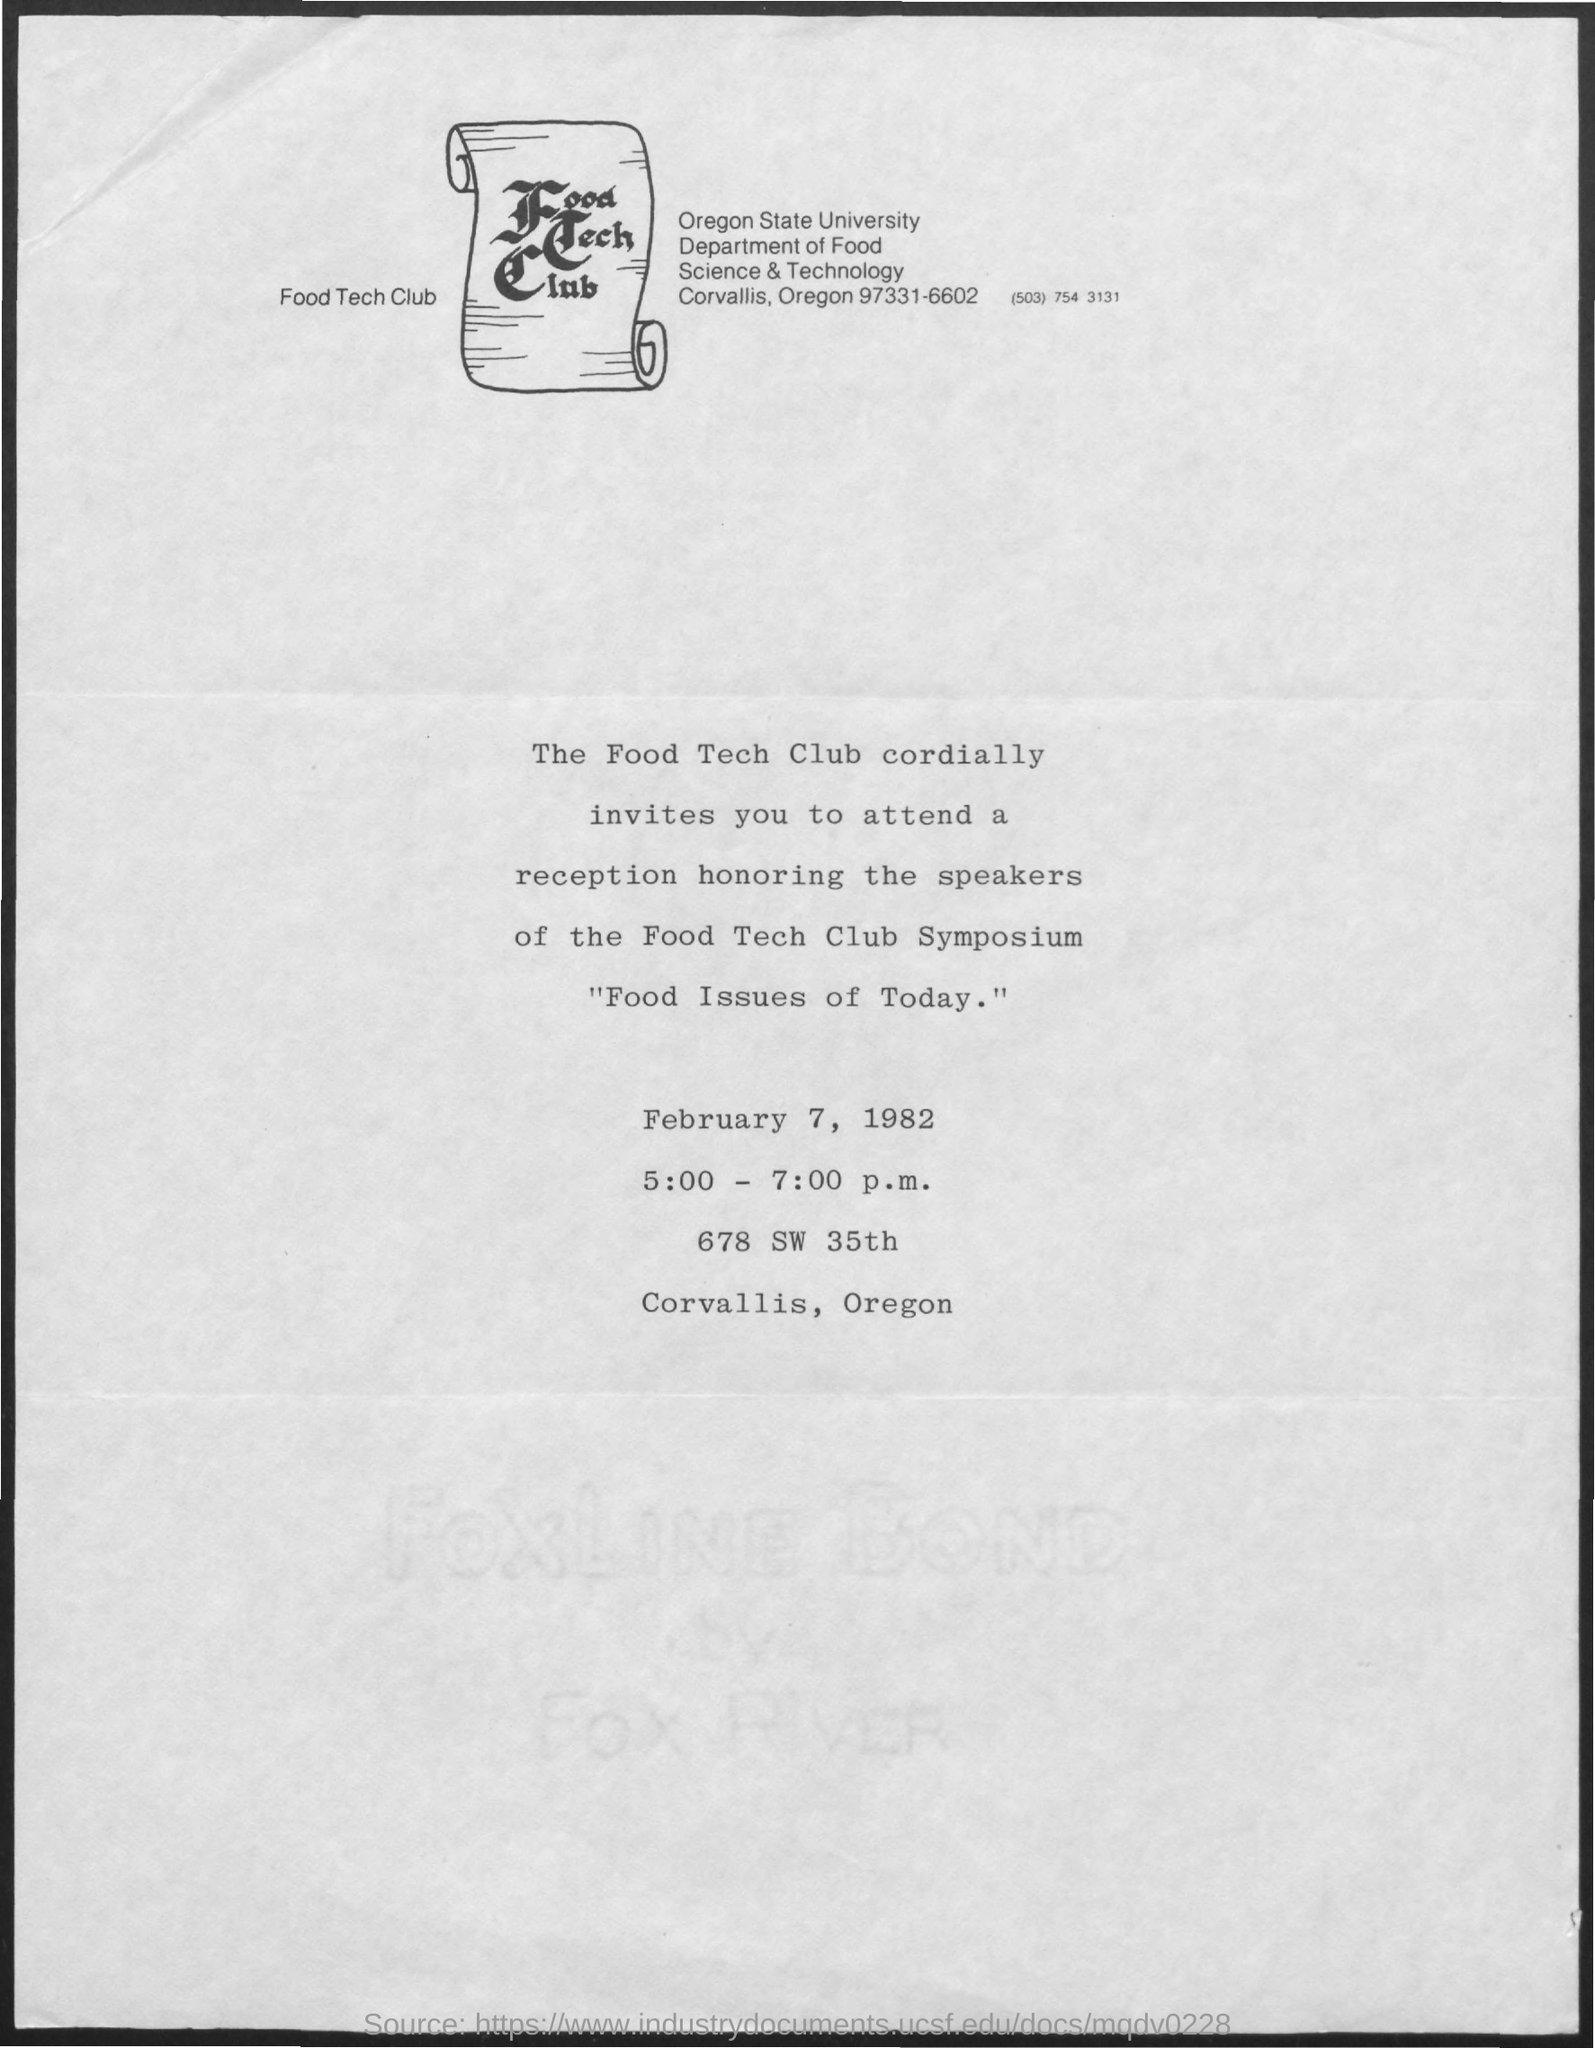Draw attention to some important aspects in this diagram. The symposium will take place on February 7, 1982. 